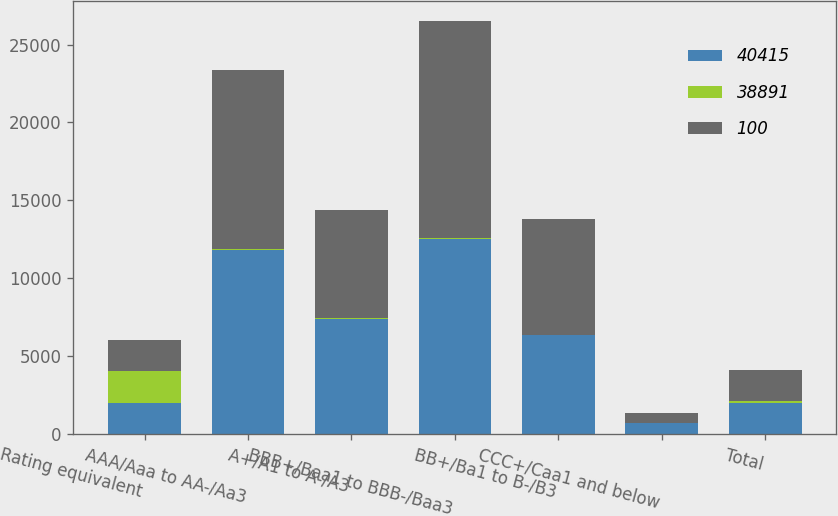Convert chart. <chart><loc_0><loc_0><loc_500><loc_500><stacked_bar_chart><ecel><fcel>Rating equivalent<fcel>AAA/Aaa to AA-/Aa3<fcel>A+/A1 to A-/A3<fcel>BBB+/Baa1 to BBB-/Baa3<fcel>BB+/Ba1 to B-/B3<fcel>CCC+/Caa1 and below<fcel>Total<nl><fcel>40415<fcel>2018<fcel>11831<fcel>7428<fcel>12536<fcel>6373<fcel>723<fcel>2018<nl><fcel>38891<fcel>2018<fcel>31<fcel>19<fcel>32<fcel>16<fcel>2<fcel>100<nl><fcel>100<fcel>2017<fcel>11529<fcel>6919<fcel>13925<fcel>7397<fcel>645<fcel>2018<nl></chart> 